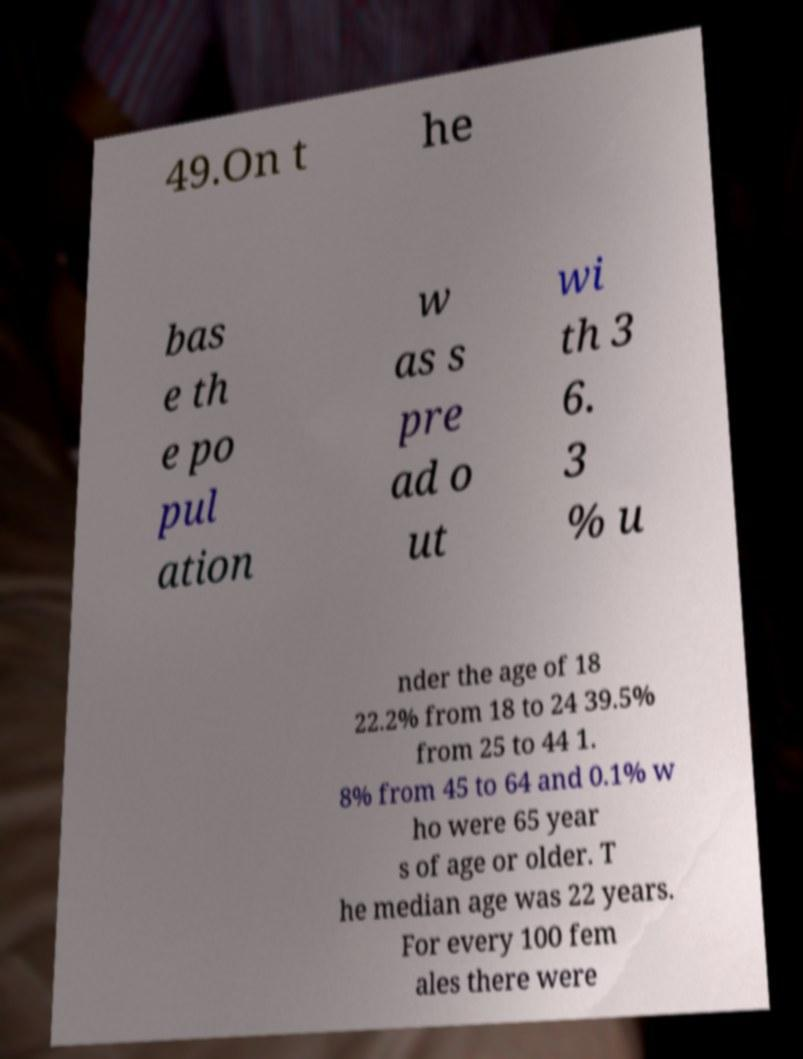There's text embedded in this image that I need extracted. Can you transcribe it verbatim? 49.On t he bas e th e po pul ation w as s pre ad o ut wi th 3 6. 3 % u nder the age of 18 22.2% from 18 to 24 39.5% from 25 to 44 1. 8% from 45 to 64 and 0.1% w ho were 65 year s of age or older. T he median age was 22 years. For every 100 fem ales there were 